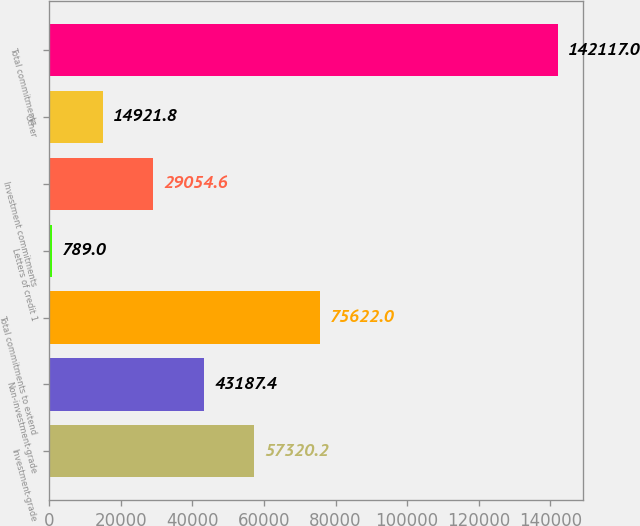<chart> <loc_0><loc_0><loc_500><loc_500><bar_chart><fcel>Investment-grade<fcel>Non-investment-grade<fcel>Total commitments to extend<fcel>Letters of credit 1<fcel>Investment commitments<fcel>Other<fcel>Total commitments<nl><fcel>57320.2<fcel>43187.4<fcel>75622<fcel>789<fcel>29054.6<fcel>14921.8<fcel>142117<nl></chart> 